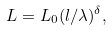<formula> <loc_0><loc_0><loc_500><loc_500>L = L _ { 0 } ( l / \lambda ) ^ { \delta } ,</formula> 